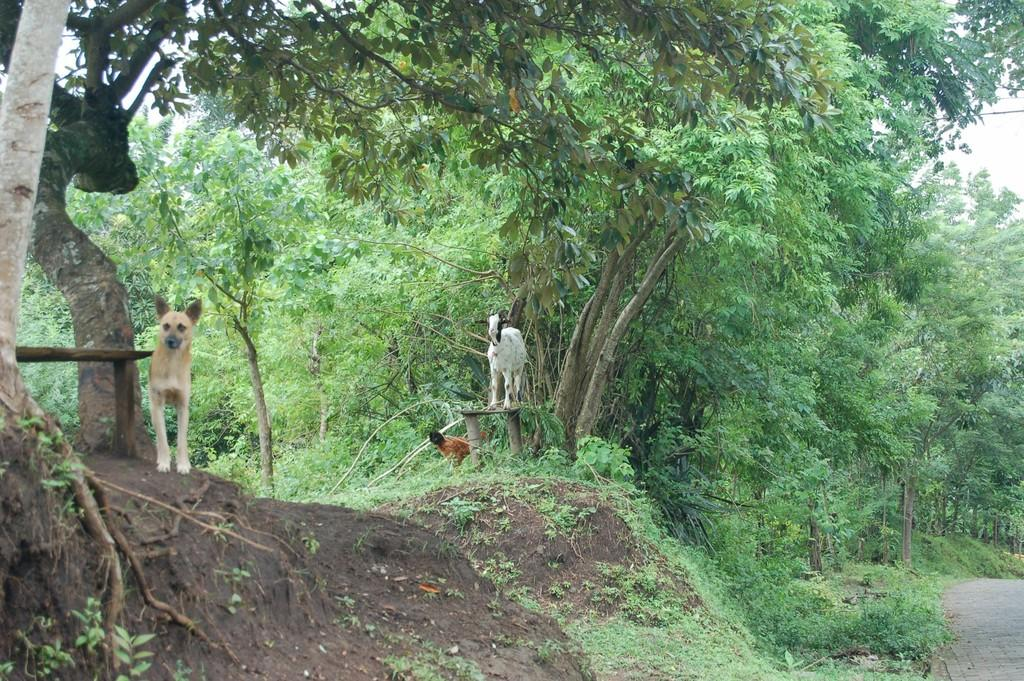What type of vegetation can be seen in the image? There are trees in the image. What animals are present in the image? There are dogs visible in the image. Where are the dogs located in relation to the trees? The dogs are in front of the trees. What time of day is it in the image, and how does the morning affect the dogs' behavior? The time of day is not mentioned in the image, and there is no indication of the dogs' behavior being affected by the morning. 